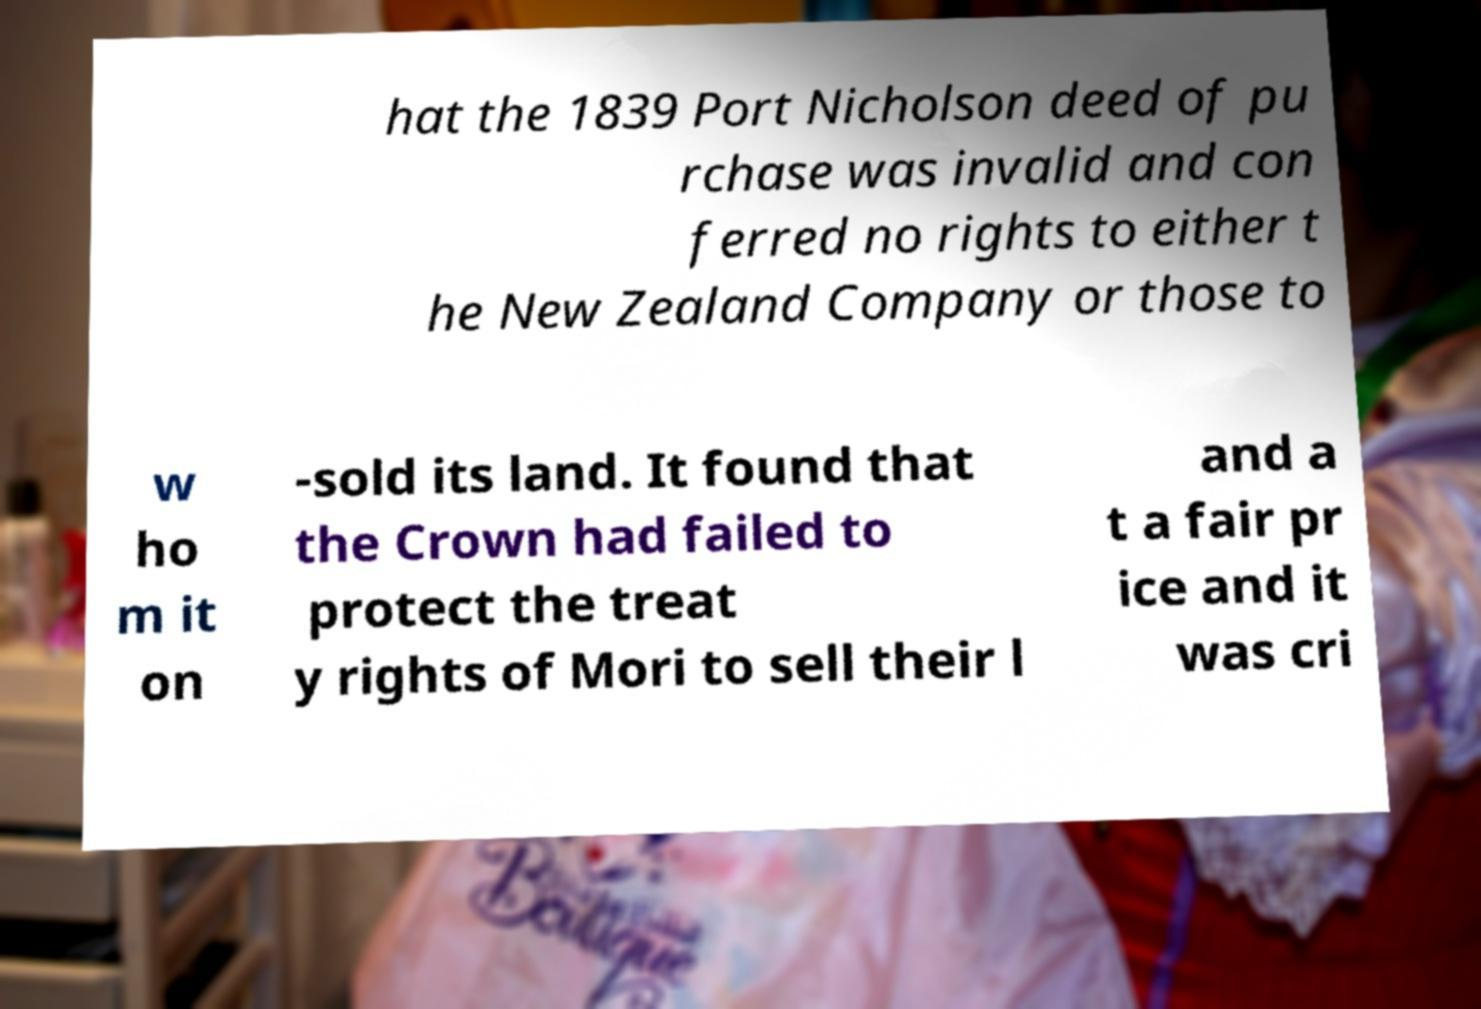There's text embedded in this image that I need extracted. Can you transcribe it verbatim? hat the 1839 Port Nicholson deed of pu rchase was invalid and con ferred no rights to either t he New Zealand Company or those to w ho m it on -sold its land. It found that the Crown had failed to protect the treat y rights of Mori to sell their l and a t a fair pr ice and it was cri 